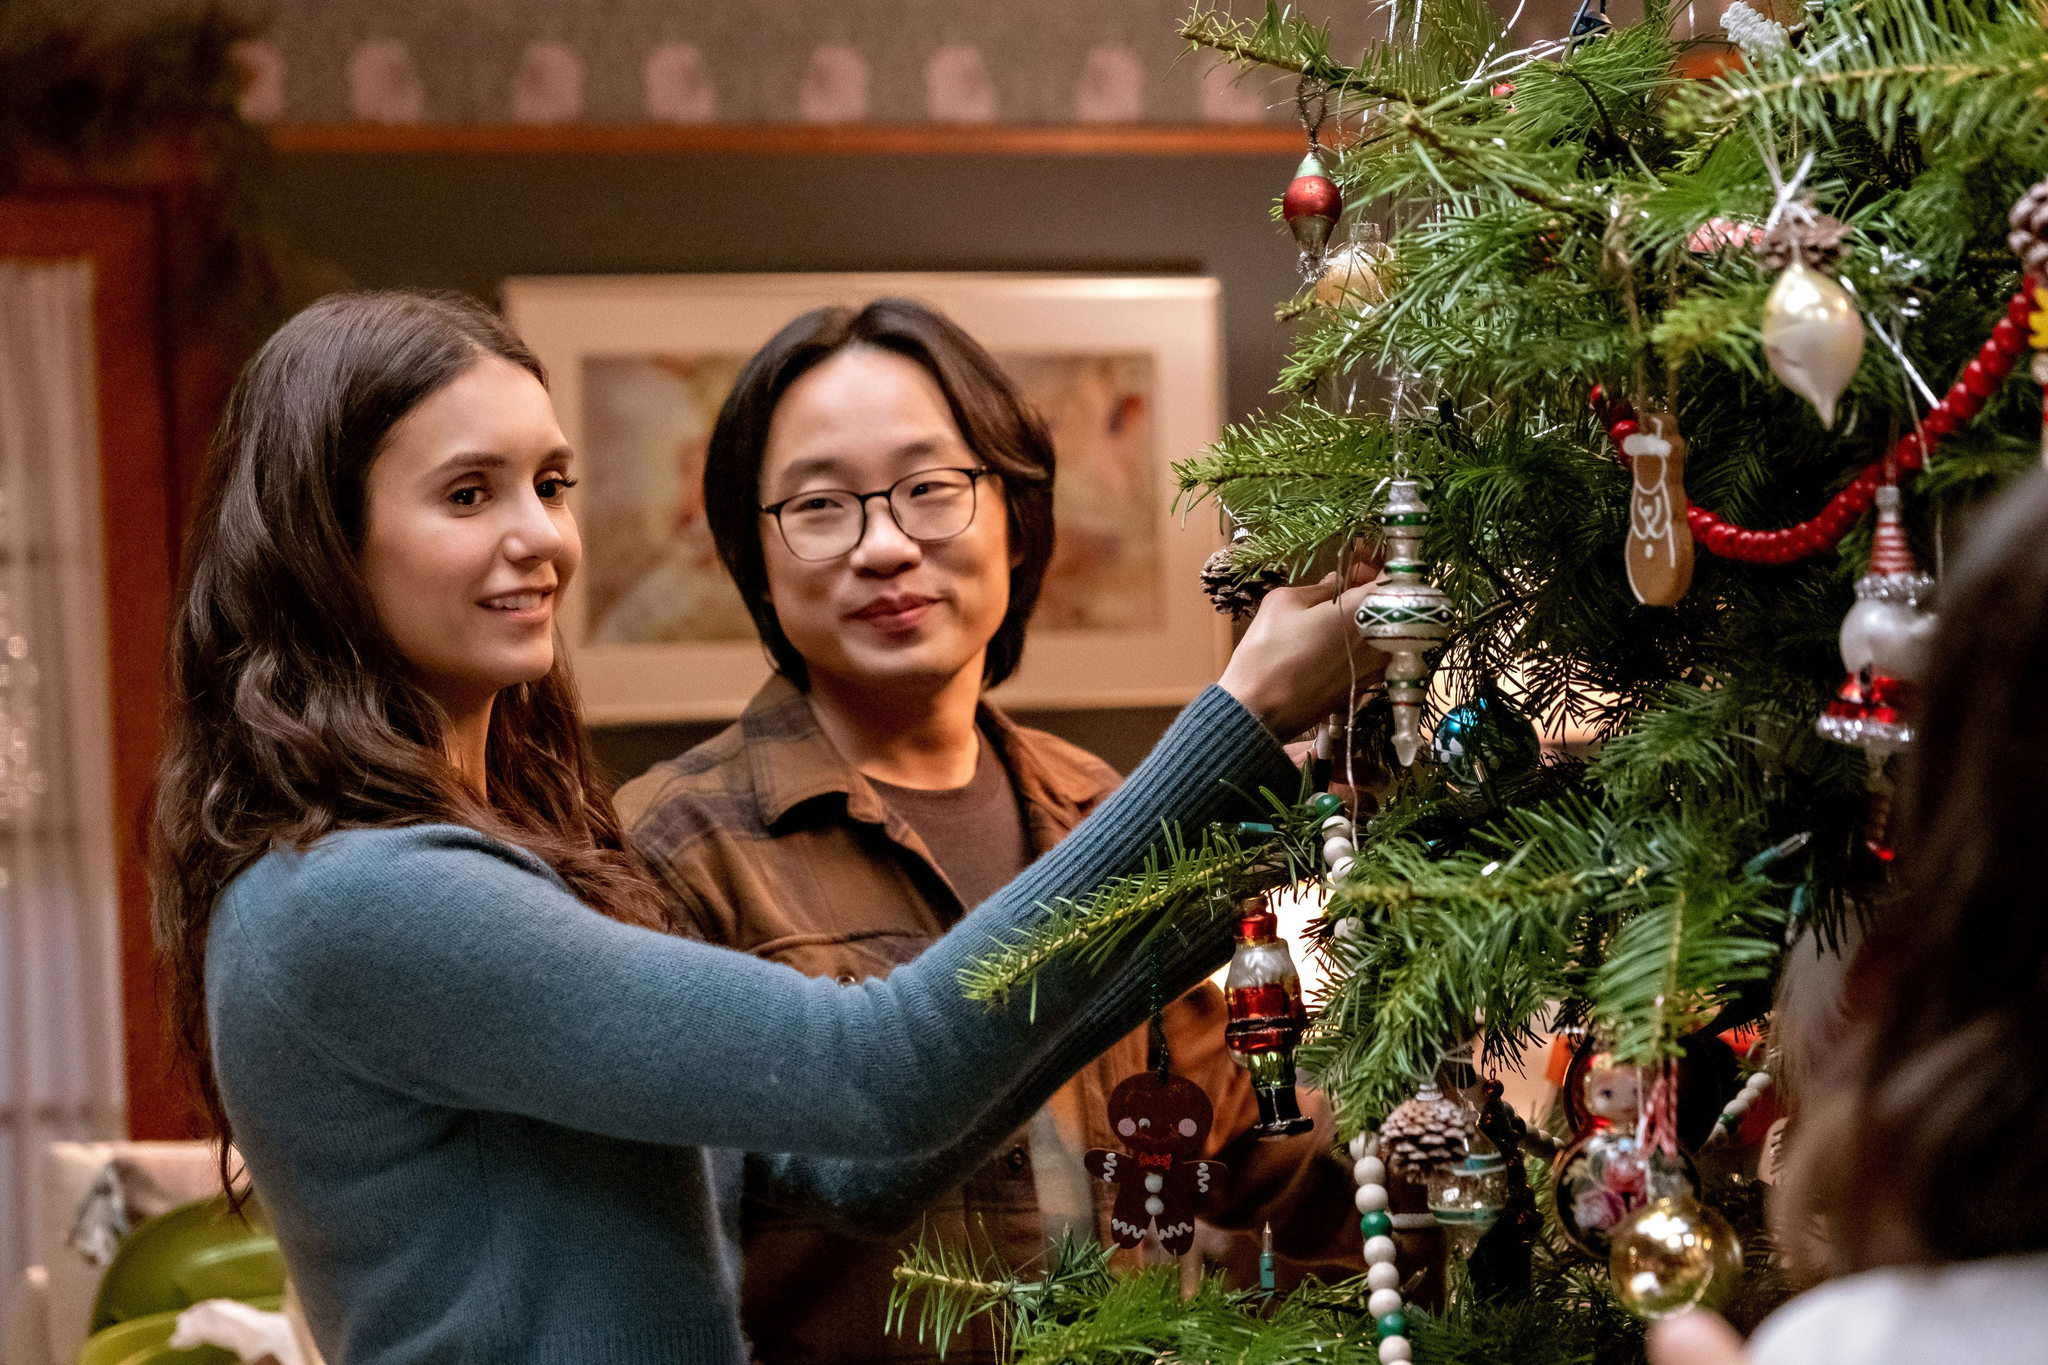Describe the following image. In this heartwarming image, we see two individuals joyfully decorating a Christmas tree. On the left side is a person wearing a cozy blue sweater, her arm extended upwards as she carefully places an ornament on the tree. Beside her, another person dressed in a casual brown shirt and glasses stands with a contented smile, mirroring her action with another ornament. The tree is beautifully adorned with a mix of festive decorations, including red and gold balls, white snowflakes, and a charming gingerbread man. This festive scene unfolds in a warmly lit living room, complete with a fireplace and tastefully framed pictures, creating a cozy holiday atmosphere. 